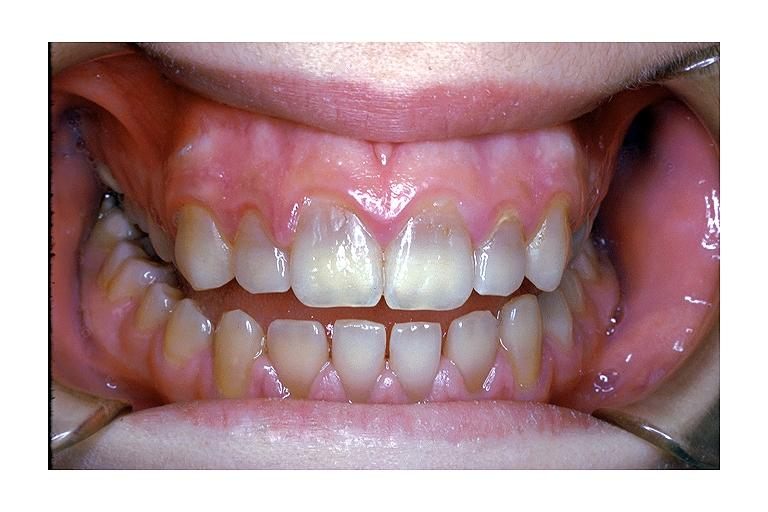s tetracycline induced discoloration?
Answer the question using a single word or phrase. Yes 